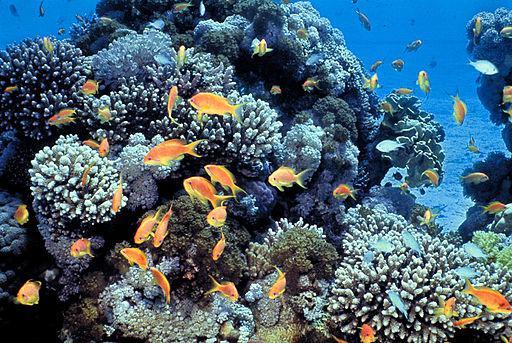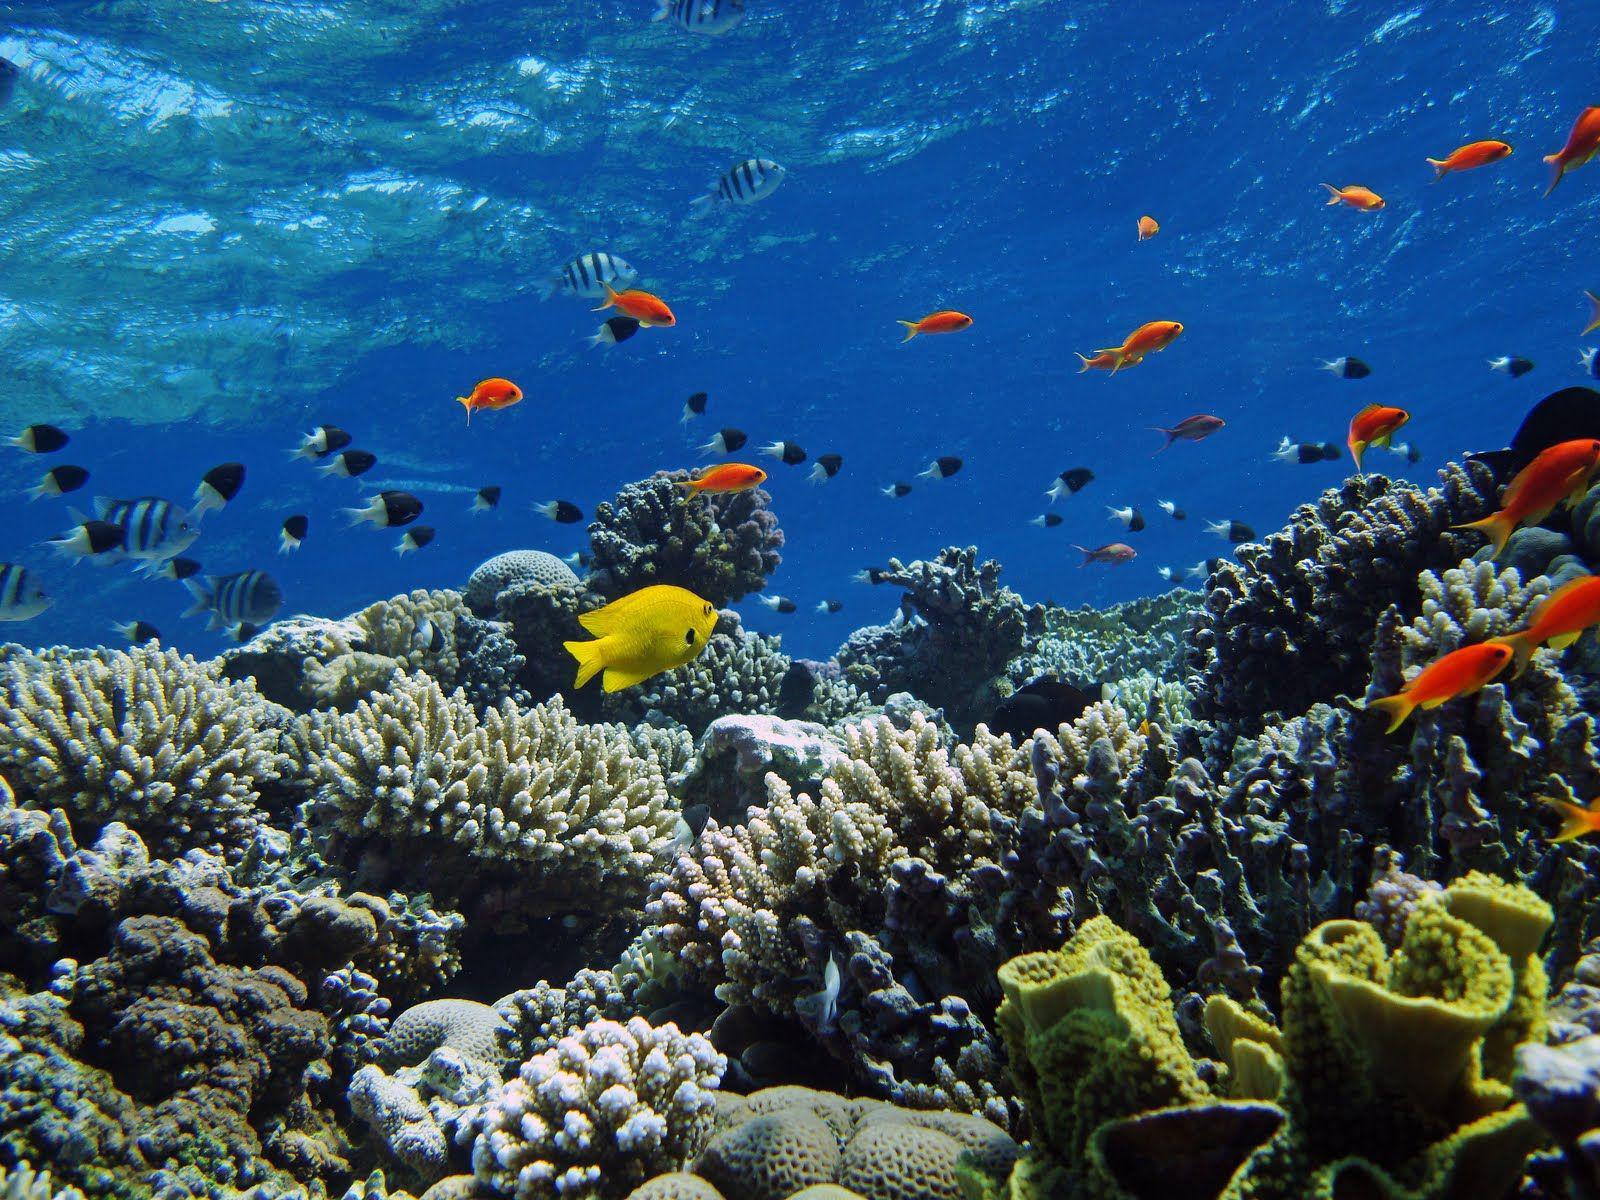The first image is the image on the left, the second image is the image on the right. Examine the images to the left and right. Is the description "There are clown fish in the left image." accurate? Answer yes or no. No. The first image is the image on the left, the second image is the image on the right. Evaluate the accuracy of this statement regarding the images: "At least one colorful fish is near the purple-tipped slender tendrils of an anemone in one image.". Is it true? Answer yes or no. No. 